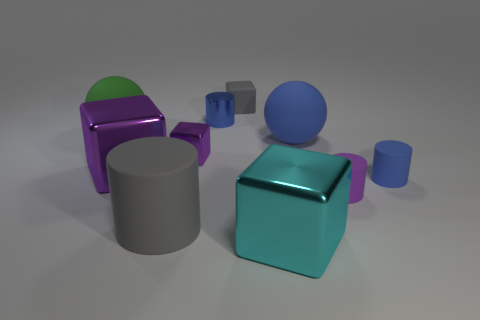Subtract all small gray cubes. How many cubes are left? 3 Subtract all cyan cubes. How many blue cylinders are left? 2 Subtract 2 cylinders. How many cylinders are left? 2 Subtract all cyan blocks. How many blocks are left? 3 Subtract all red blocks. Subtract all green spheres. How many blocks are left? 4 Subtract all spheres. How many objects are left? 8 Add 1 rubber blocks. How many rubber blocks exist? 2 Subtract 0 cyan cylinders. How many objects are left? 10 Subtract all cyan metal things. Subtract all blue matte things. How many objects are left? 7 Add 8 large blue objects. How many large blue objects are left? 9 